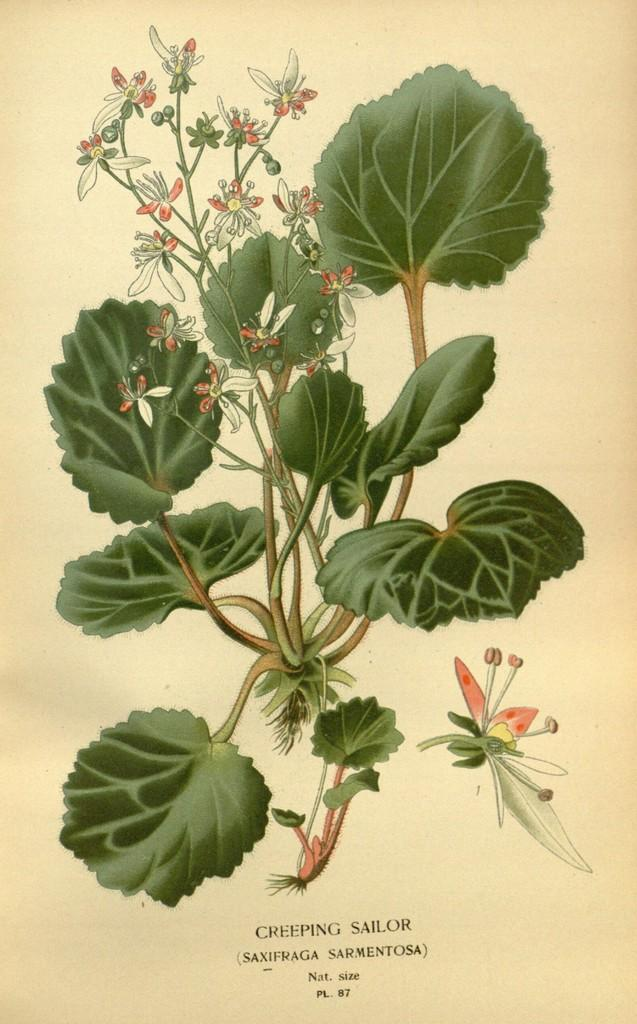What is depicted on the paper in the image? There is a plant with flowers on the paper. Are there any other elements on the paper besides the plant? Yes, there are words and numbers on the paper. What type of toys can be seen on the paper in the image? There are no toys present on the paper in the image. Is there a book depicted on the paper in the image? There is no book depicted on the paper in the image. 